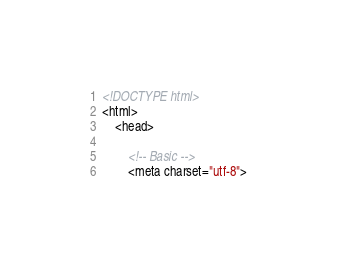<code> <loc_0><loc_0><loc_500><loc_500><_HTML_><!DOCTYPE html>
<html>
	<head>

		<!-- Basic -->
		<meta charset="utf-8"></code> 